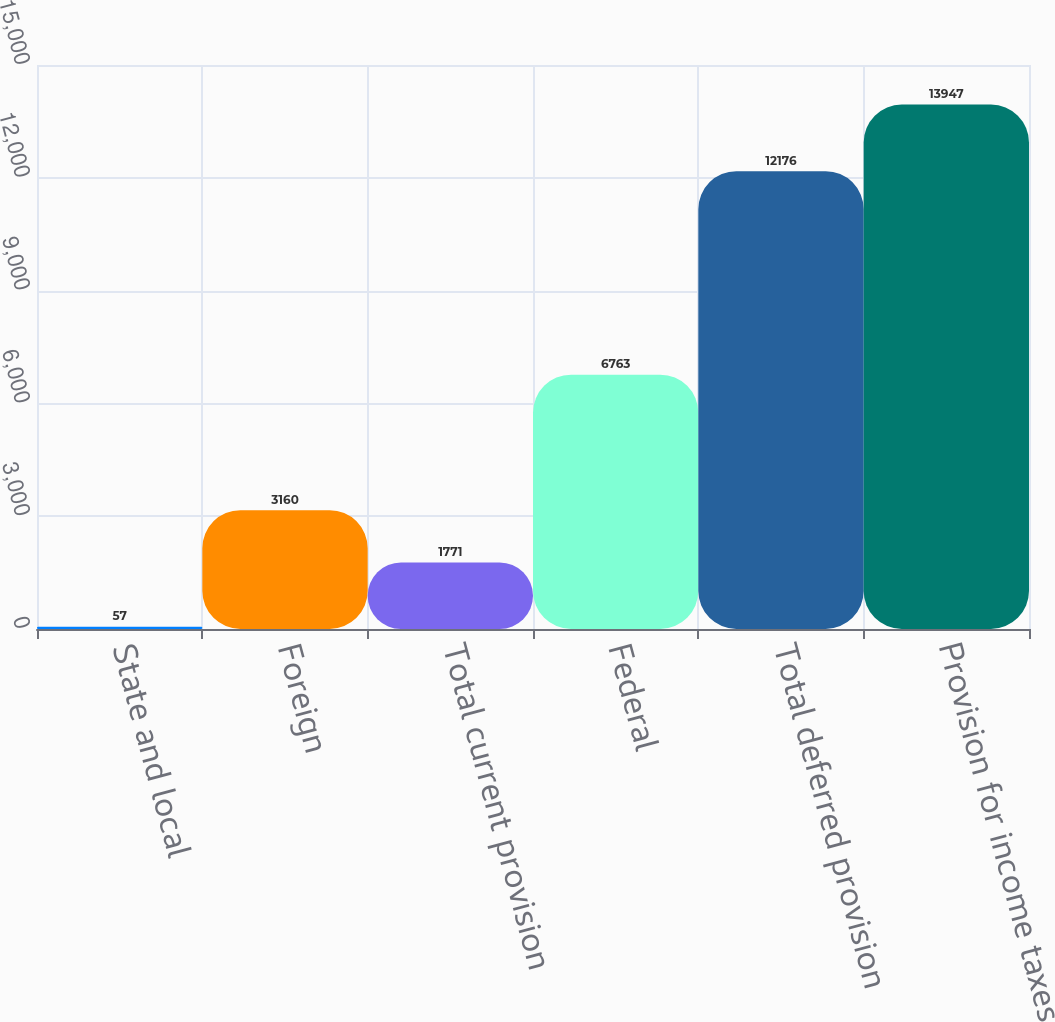Convert chart. <chart><loc_0><loc_0><loc_500><loc_500><bar_chart><fcel>State and local<fcel>Foreign<fcel>Total current provision<fcel>Federal<fcel>Total deferred provision<fcel>Provision for income taxes<nl><fcel>57<fcel>3160<fcel>1771<fcel>6763<fcel>12176<fcel>13947<nl></chart> 